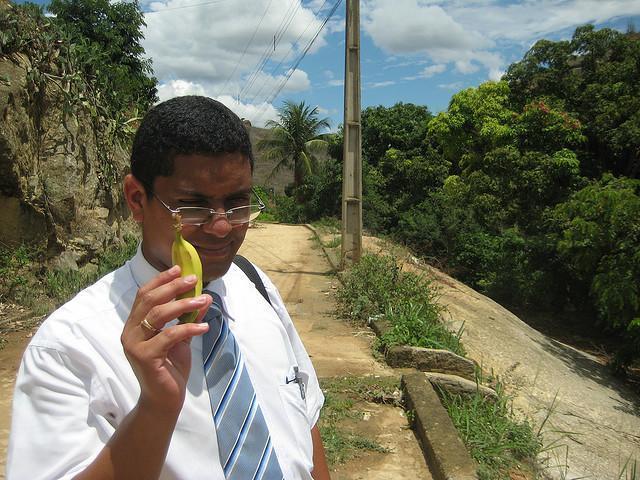How many skateboards do you see?
Give a very brief answer. 0. 